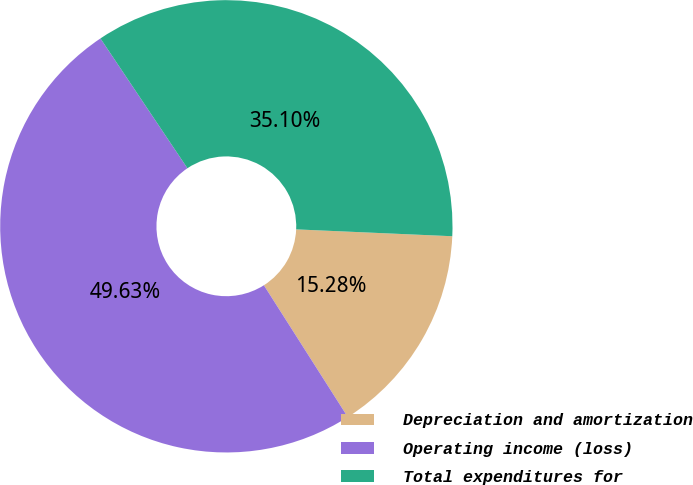<chart> <loc_0><loc_0><loc_500><loc_500><pie_chart><fcel>Depreciation and amortization<fcel>Operating income (loss)<fcel>Total expenditures for<nl><fcel>15.28%<fcel>49.63%<fcel>35.1%<nl></chart> 